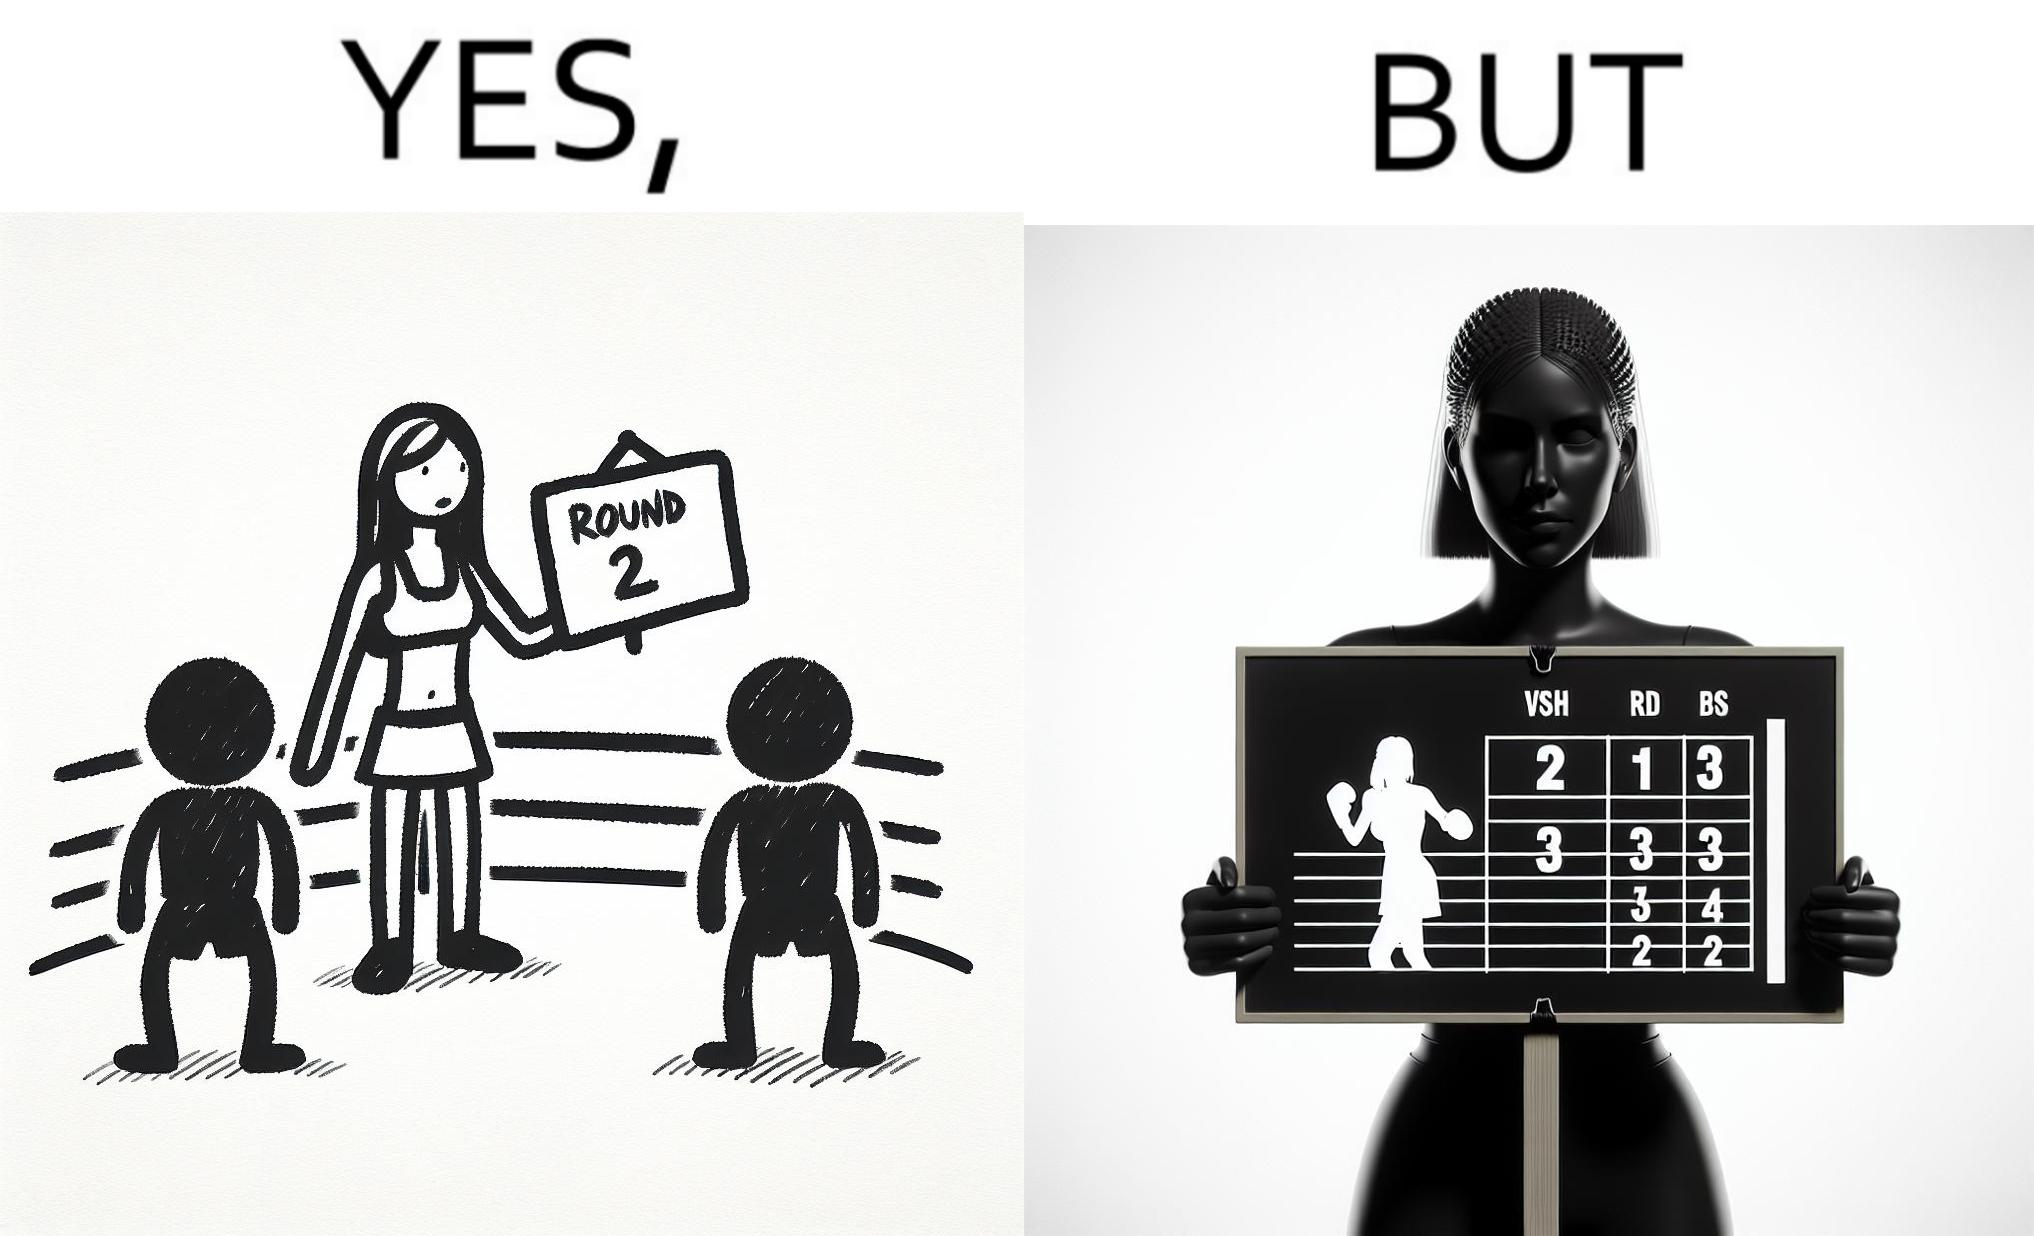Does this image contain satire or humor? Yes, this image is satirical. 